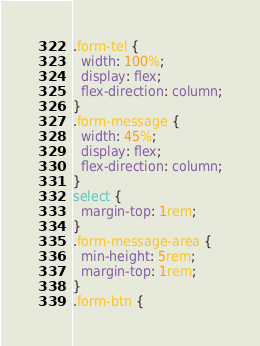Convert code to text. <code><loc_0><loc_0><loc_500><loc_500><_CSS_>.form-tel {
  width: 100%;
  display: flex;
  flex-direction: column;
}
.form-message {
  width: 45%;
  display: flex;
  flex-direction: column;
}
select {
  margin-top: 1rem;
}
.form-message-area {
  min-height: 5rem;
  margin-top: 1rem;
}
.form-btn {</code> 